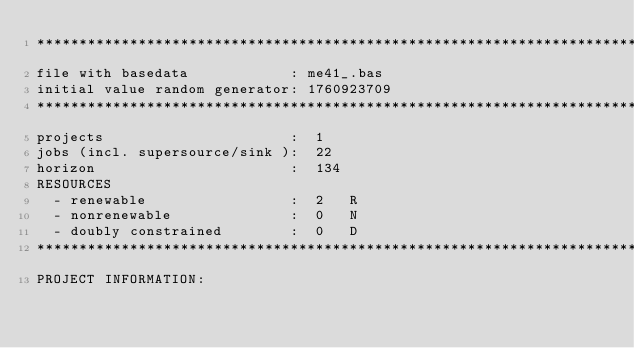Convert code to text. <code><loc_0><loc_0><loc_500><loc_500><_ObjectiveC_>************************************************************************
file with basedata            : me41_.bas
initial value random generator: 1760923709
************************************************************************
projects                      :  1
jobs (incl. supersource/sink ):  22
horizon                       :  134
RESOURCES
  - renewable                 :  2   R
  - nonrenewable              :  0   N
  - doubly constrained        :  0   D
************************************************************************
PROJECT INFORMATION:</code> 